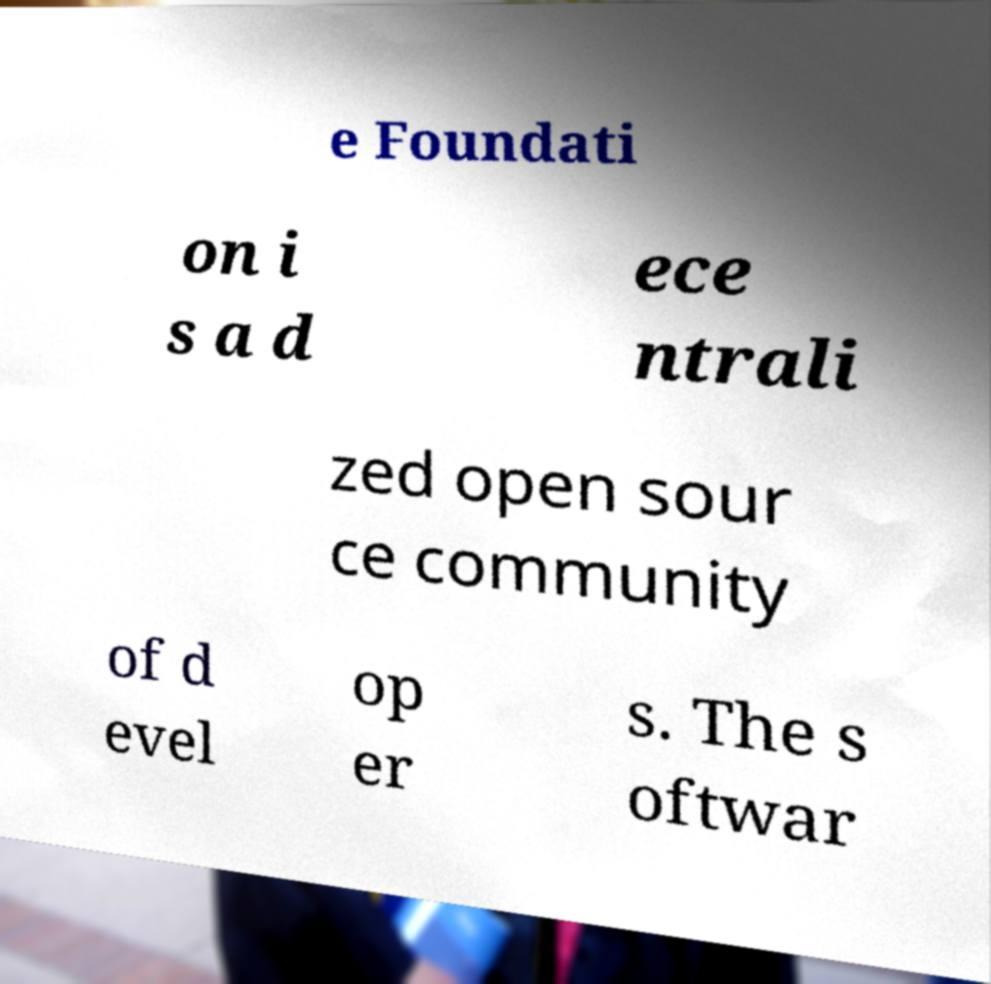Please read and relay the text visible in this image. What does it say? e Foundati on i s a d ece ntrali zed open sour ce community of d evel op er s. The s oftwar 